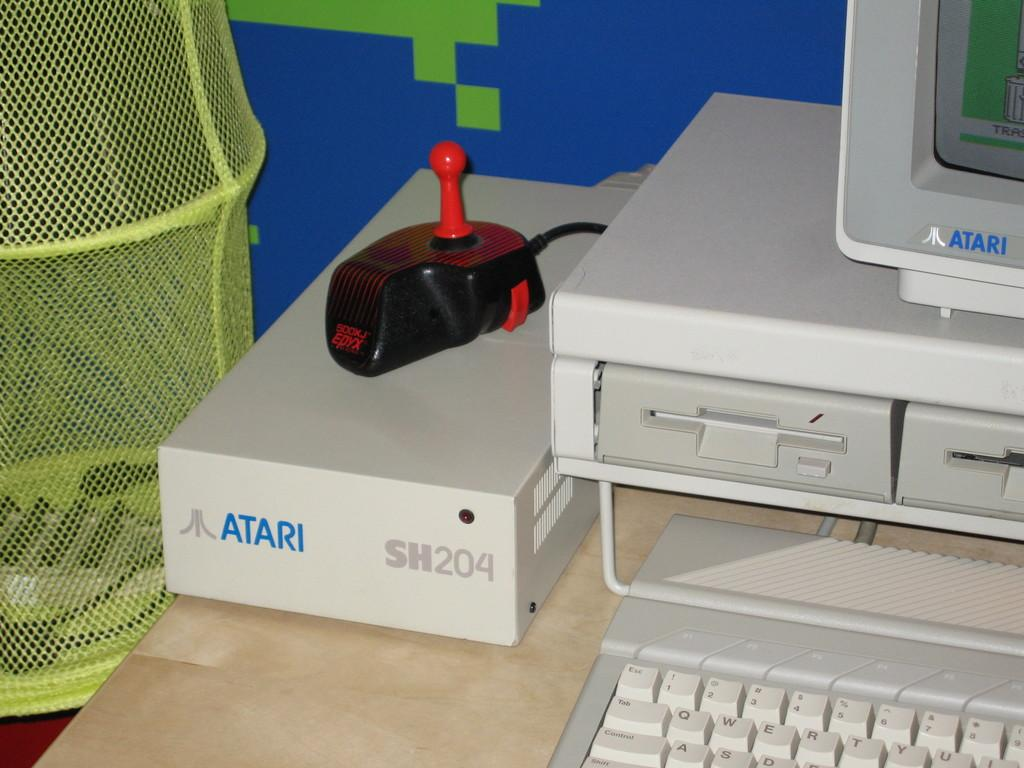What electronic device is visible on the table in the image? There is an electronic device on the table in the image. What is the primary input device for the electronic device? There is a keyboard in the image. What is the primary display device for the electronic device? There is a monitor screen in the image. What color is the mesh on the left side of the image? The mesh on the left side of the image is green. How many chances does the achiever have to win the game in the image? There is no game or achiever present in the image; it features an electronic device, a keyboard, a monitor screen, and a green mesh. 